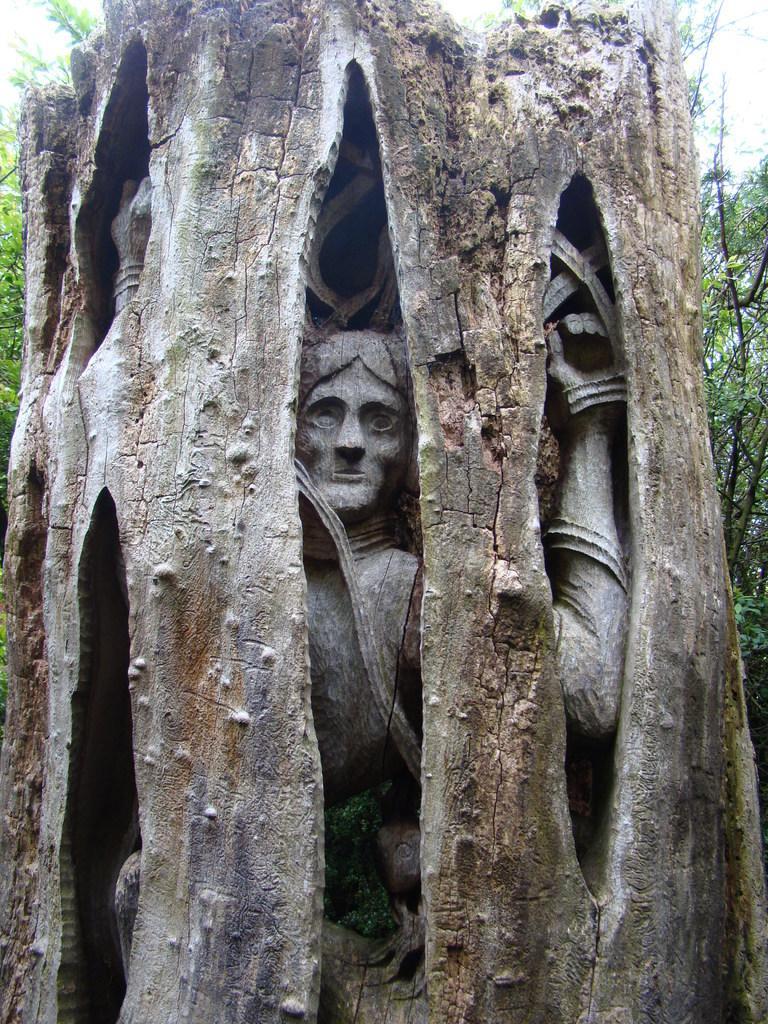Please provide a concise description of this image. In this picture we can see a statue in the tree, in the background we can find few more trees. 